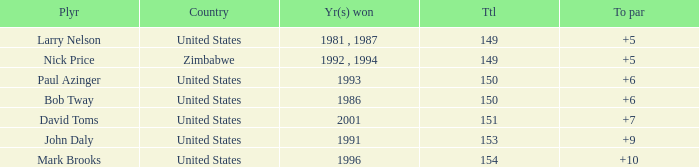What is the total for 1986 with a to par higher than 6? 0.0. 